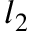<formula> <loc_0><loc_0><loc_500><loc_500>l _ { 2 }</formula> 